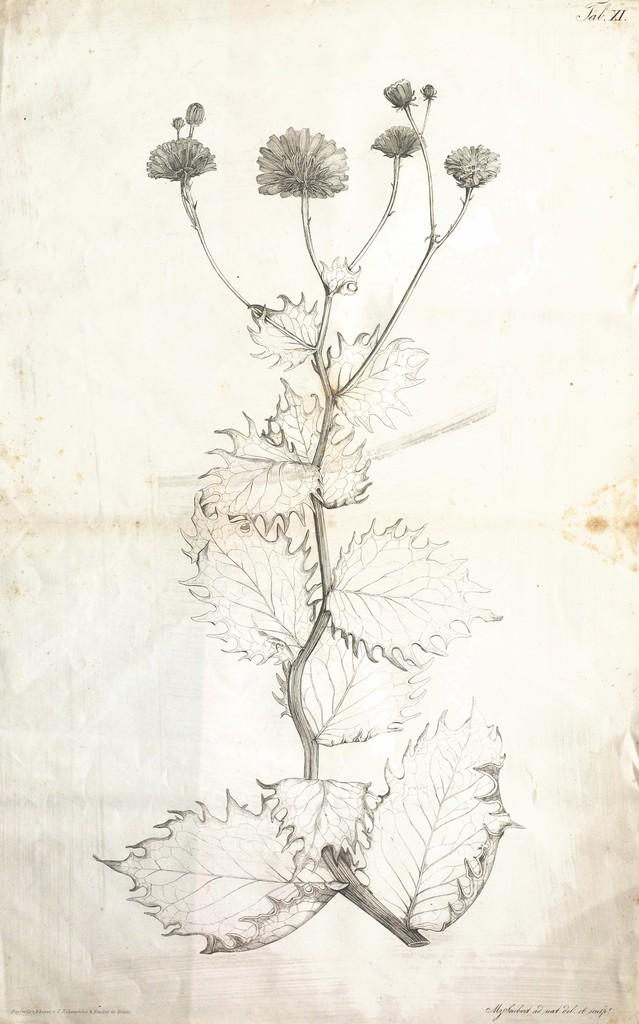What is depicted in the image? There is a picture of a plant in the image. What is the medium of the plant image? The picture of the plant is on a paper. What is the smell of the plant in the image? The image is not capable of emitting a smell, so it is not possible to determine the scent of the plant in the image. 